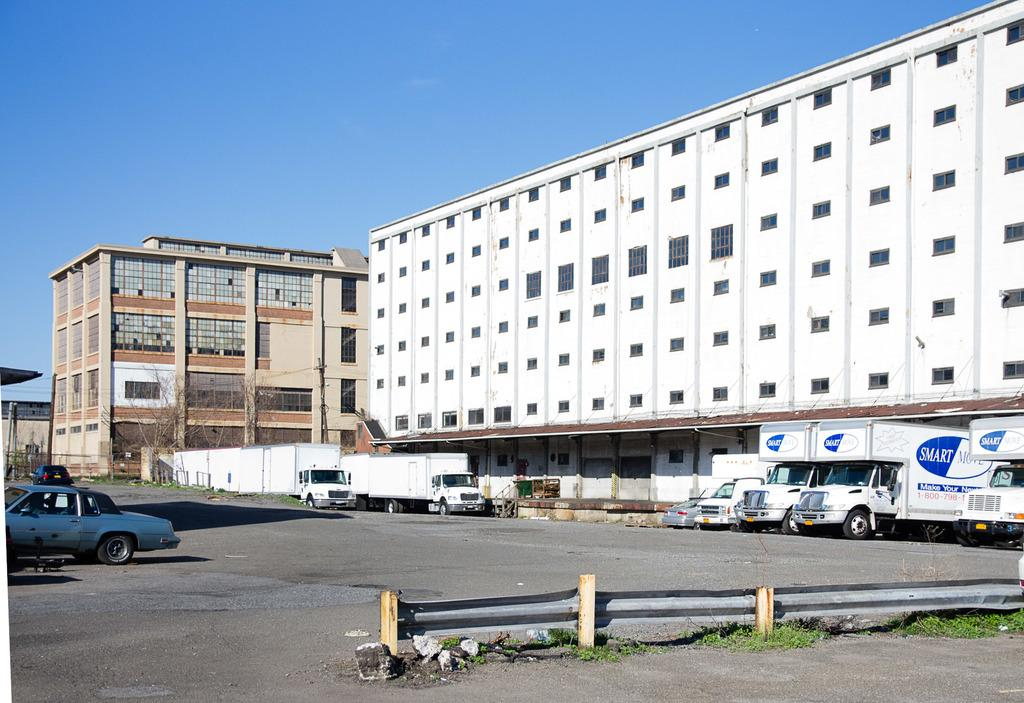What types of objects are present in the image? There are vehicles in the image. What kind of barrier can be seen in the image? There is fencing in the image. What can be seen in the distance in the image? There are buildings in the background of the image. What colors are the buildings in the background? The buildings are in white and cream color. What type of vegetation is present in the background of the image? There are dried trees in the background of the image. What is the color of the sky in the image? The sky is blue in color. Can you tell me how many circles are present in the image? There are no circles present in the image. What type of carriage can be seen in the image? There is no carriage present in the image. 